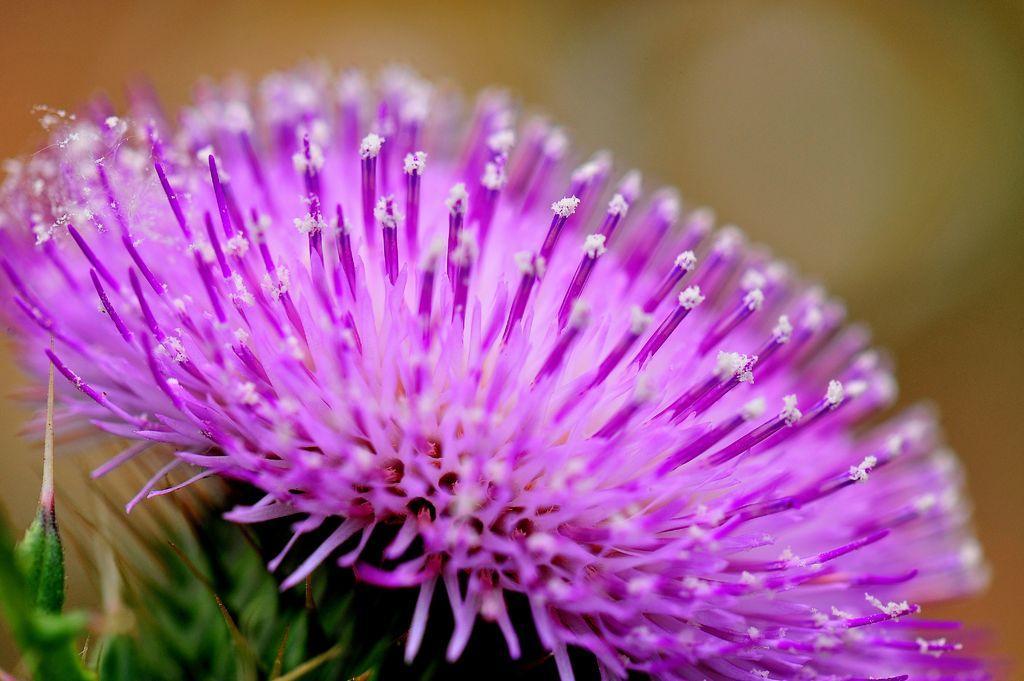Describe this image in one or two sentences. In this image we can see a flower. 